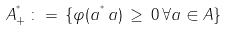<formula> <loc_0><loc_0><loc_500><loc_500>A ^ { ^ { * } } _ { + } \, \colon = \, \{ \varphi ( a ^ { ^ { * } } \, a ) \, \geq \, 0 \, \forall a \in A \}</formula> 